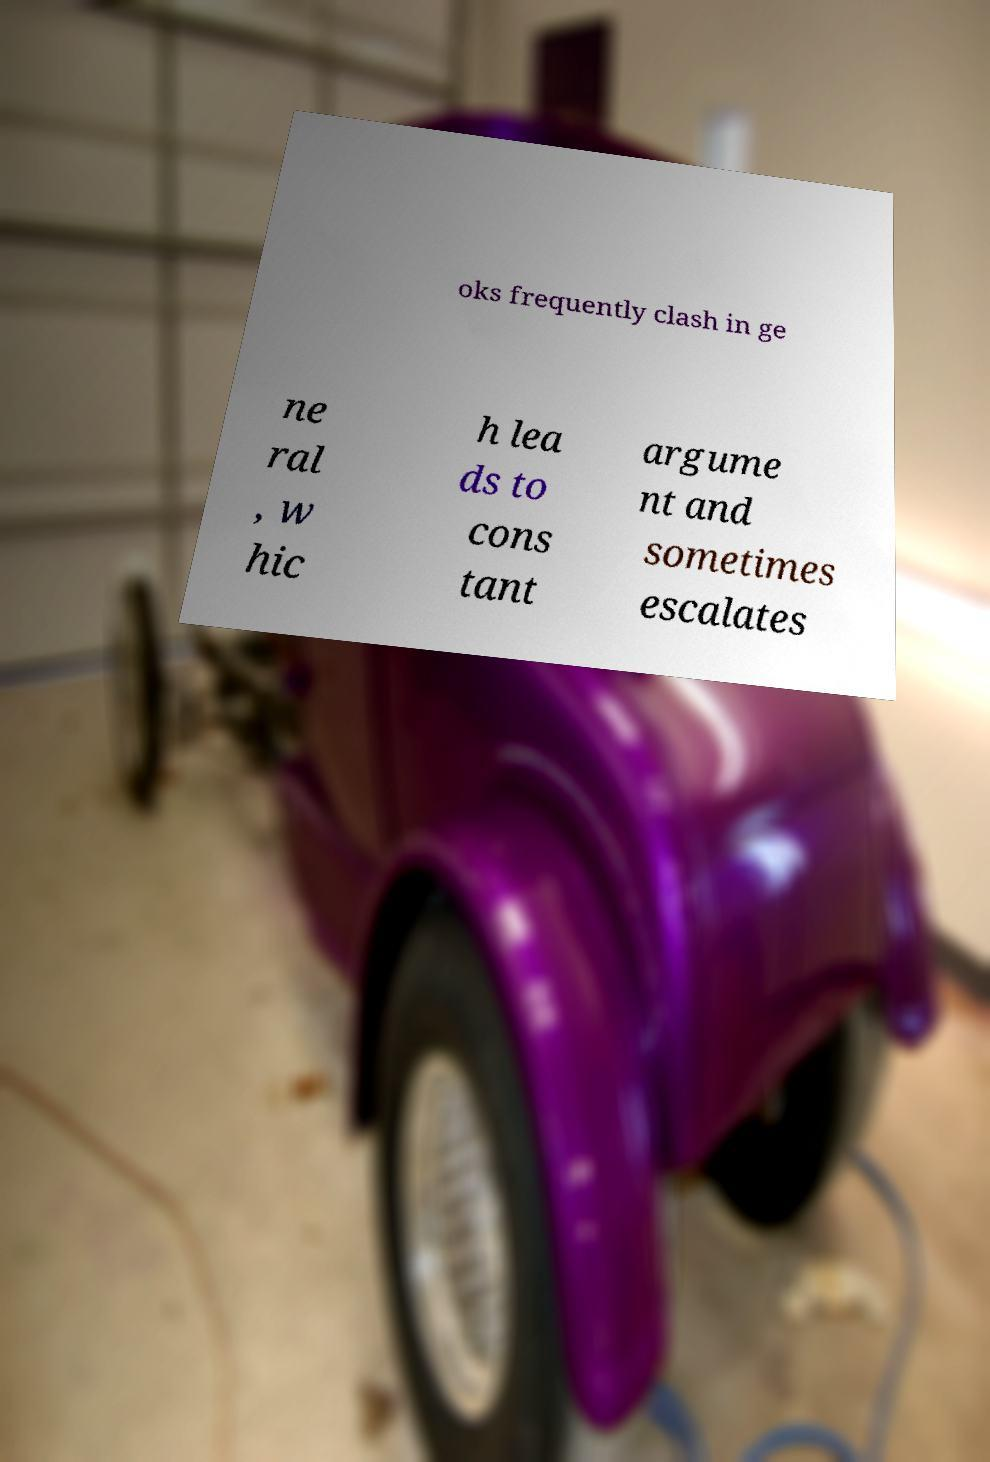Can you read and provide the text displayed in the image?This photo seems to have some interesting text. Can you extract and type it out for me? oks frequently clash in ge ne ral , w hic h lea ds to cons tant argume nt and sometimes escalates 